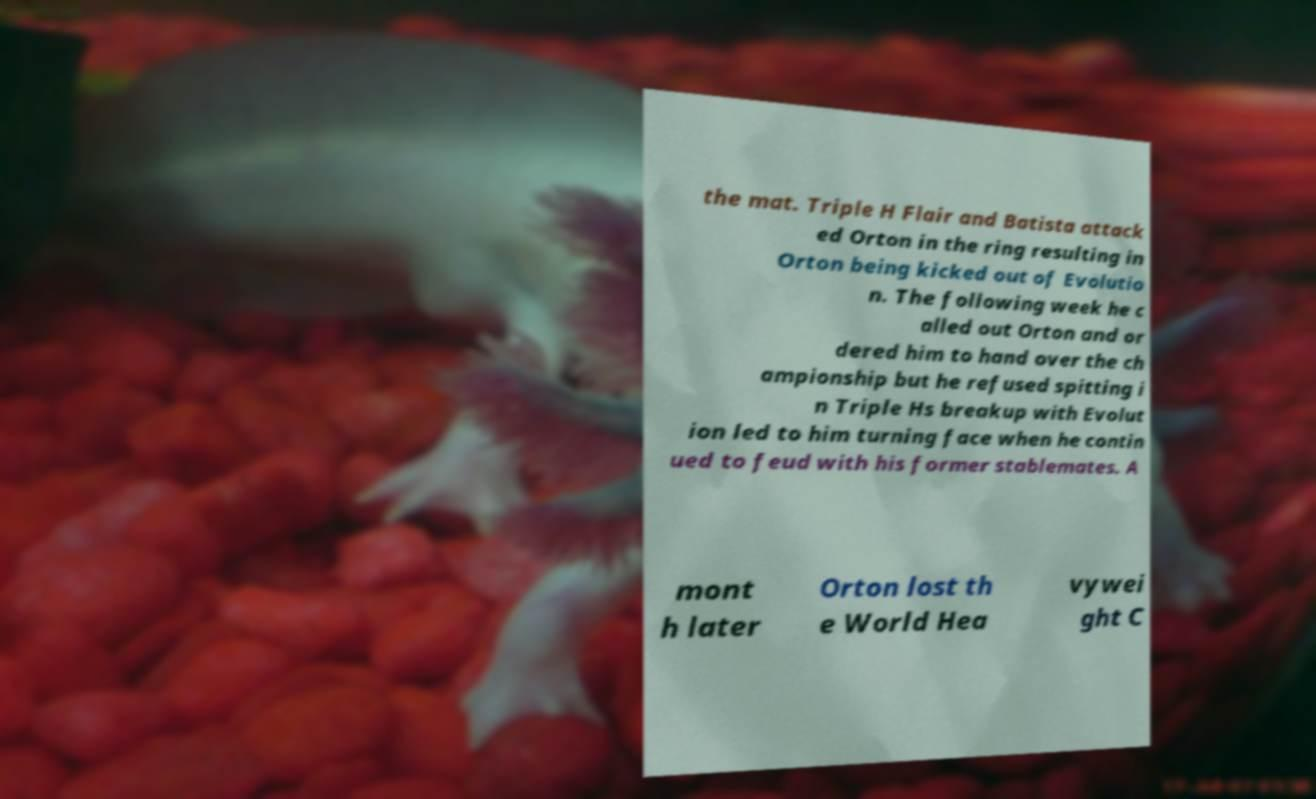I need the written content from this picture converted into text. Can you do that? the mat. Triple H Flair and Batista attack ed Orton in the ring resulting in Orton being kicked out of Evolutio n. The following week he c alled out Orton and or dered him to hand over the ch ampionship but he refused spitting i n Triple Hs breakup with Evolut ion led to him turning face when he contin ued to feud with his former stablemates. A mont h later Orton lost th e World Hea vywei ght C 